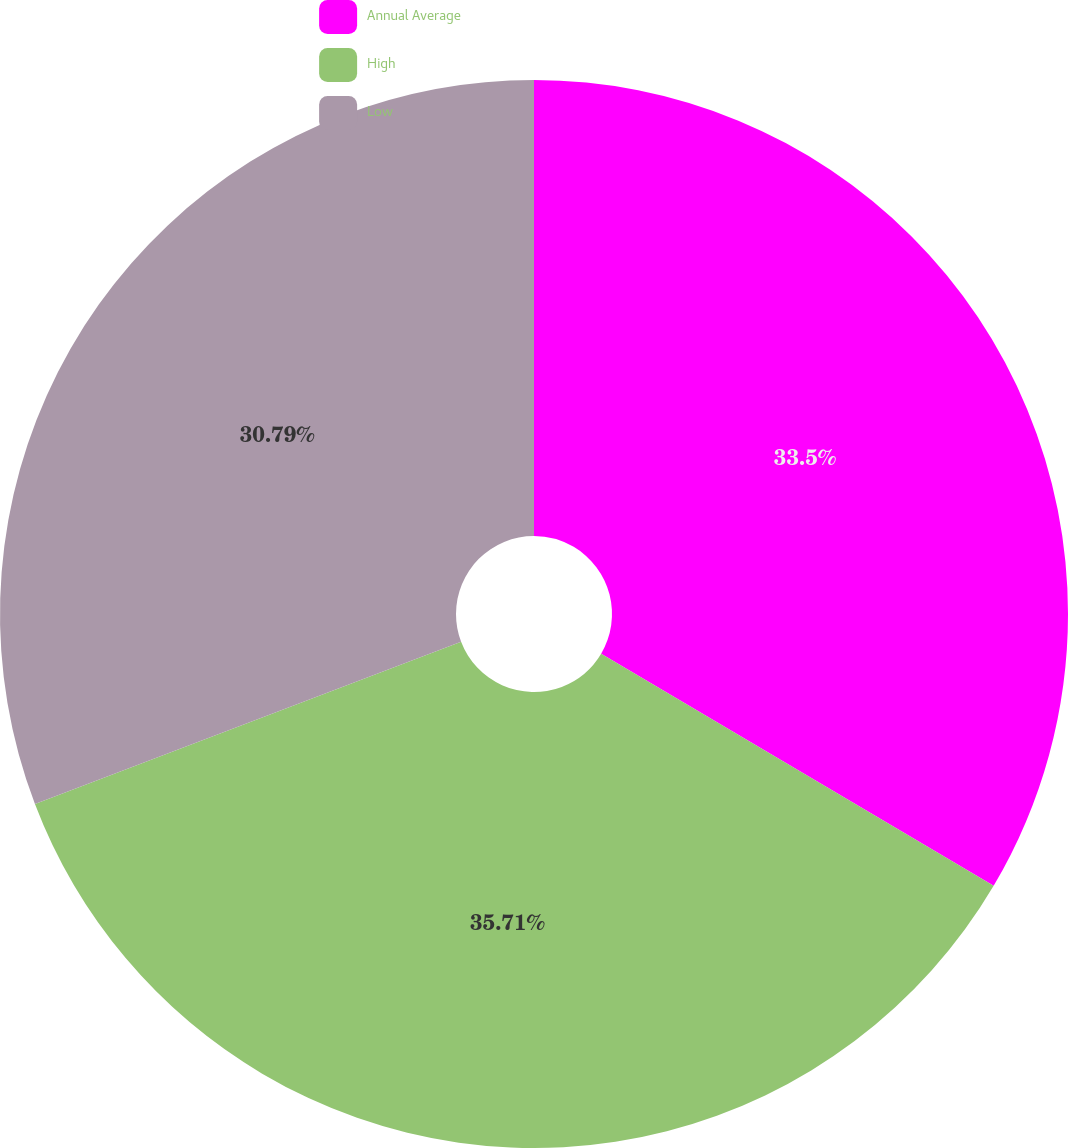<chart> <loc_0><loc_0><loc_500><loc_500><pie_chart><fcel>Annual Average<fcel>High<fcel>Low<nl><fcel>33.5%<fcel>35.71%<fcel>30.79%<nl></chart> 